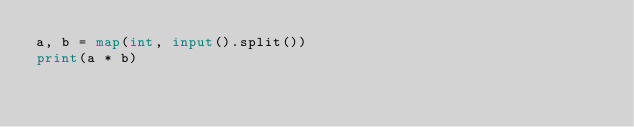Convert code to text. <code><loc_0><loc_0><loc_500><loc_500><_Python_>a, b = map(int, input().split())
print(a * b)
</code> 